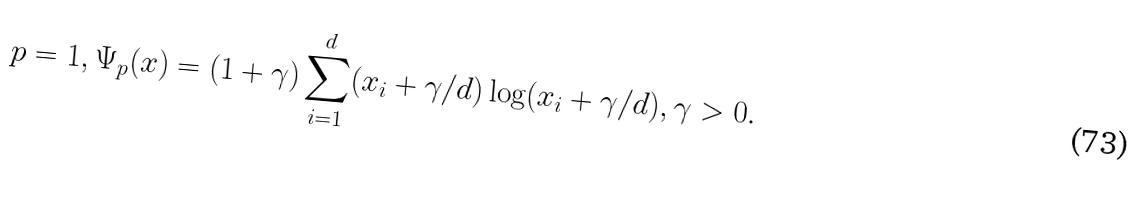<formula> <loc_0><loc_0><loc_500><loc_500>p = 1 , \Psi _ { p } ( x ) = ( 1 + \gamma ) \sum _ { i = 1 } ^ { d } ( x _ { i } + \gamma / d ) \log ( x _ { i } + \gamma / d ) , \gamma > 0 .</formula> 